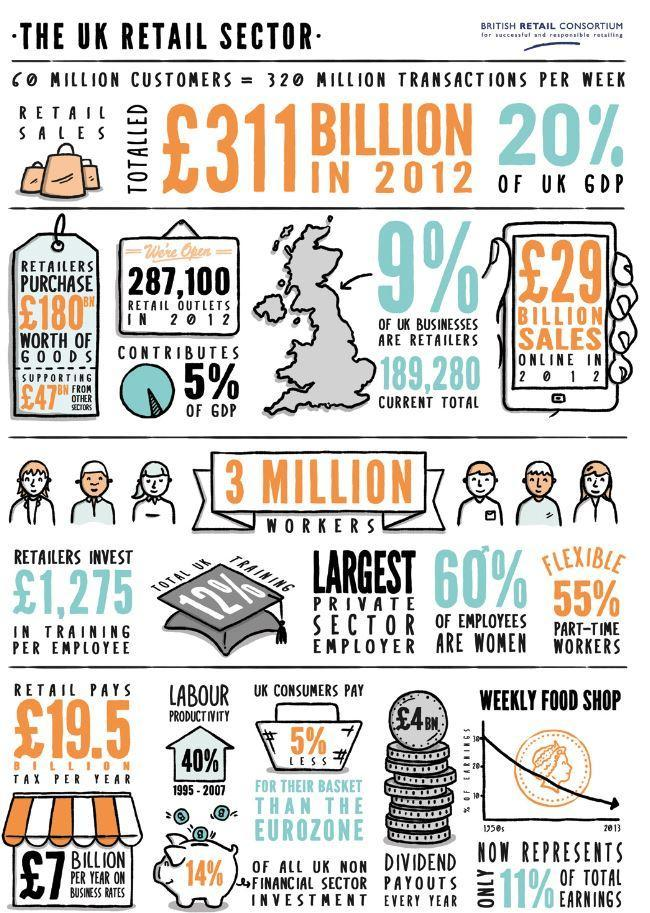How many people were working in UK's retail sector in 2012?
Answer the question with a short phrase. 3 MILLION What is the number of retail outlets in UK in 2012? 287,100 What percentage does retail sales contribute to the UK's GDP in 2012? 20% What percentage of labour productivity was achieved by UK during 1995-2007? 40% What percentage of employees working in UK's retail sector were men in 2012? 40% How much sales were achieved by the retail sector in UK in 2012? £29 BILLION SALES 